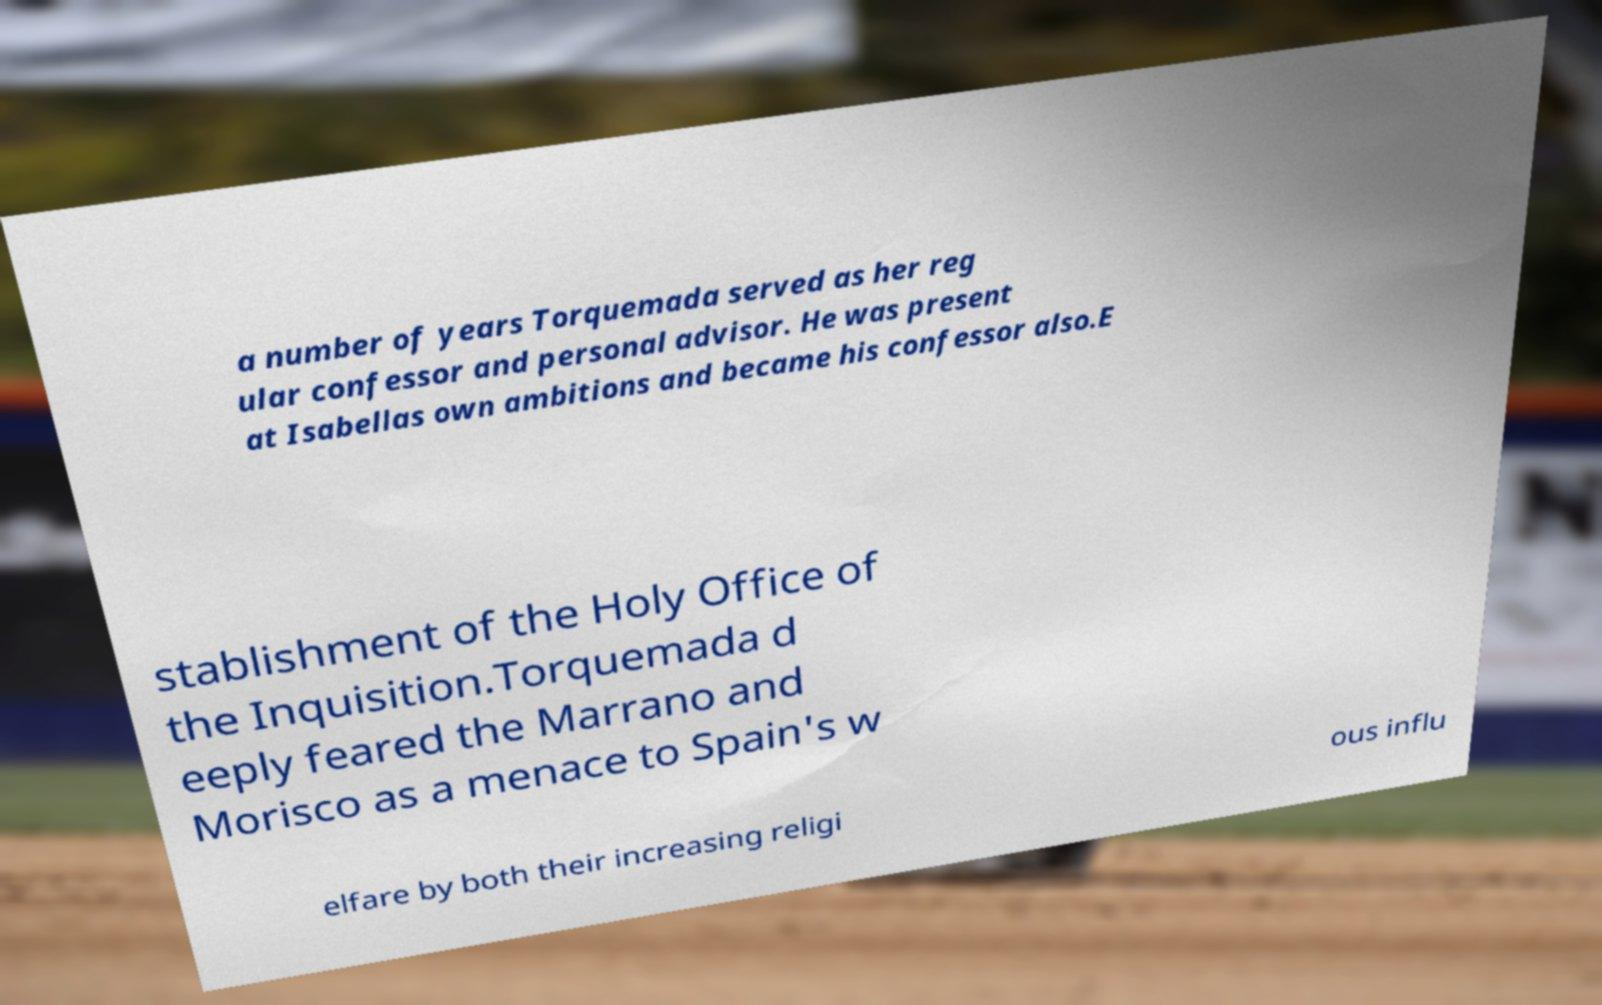What messages or text are displayed in this image? I need them in a readable, typed format. a number of years Torquemada served as her reg ular confessor and personal advisor. He was present at Isabellas own ambitions and became his confessor also.E stablishment of the Holy Office of the Inquisition.Torquemada d eeply feared the Marrano and Morisco as a menace to Spain's w elfare by both their increasing religi ous influ 